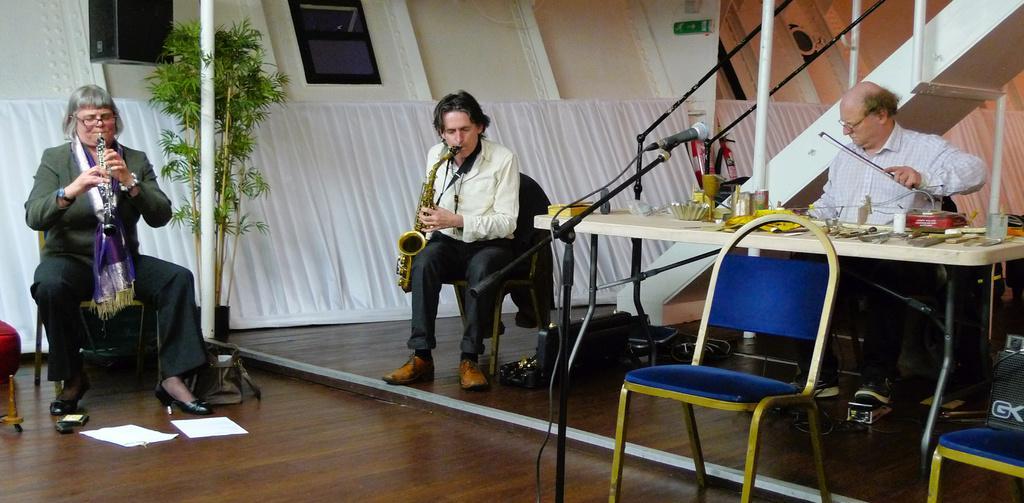Could you give a brief overview of what you see in this image? In this picture there are three people sitting and playing musical instruments and there are objects on the table and there is a microphone and there are chairs. At the back there is a staircase and there is a board. At the bottom there are papers and there are objects on the floor. On the left side of the image there is a plant and there is a chair. 